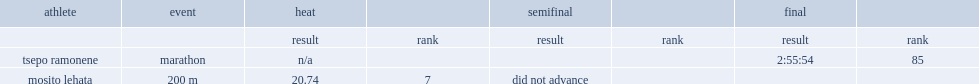I'm looking to parse the entire table for insights. Could you assist me with that? {'header': ['athlete', 'event', 'heat', '', 'semifinal', '', 'final', ''], 'rows': [['', '', 'result', 'rank', 'result', 'rank', 'result', 'rank'], ['tsepo ramonene', 'marathon', 'n/a', '', '', '', '2:55:54', '85'], ['mosito lehata', '200 m', '20.74', '7', 'did not advance', '', '', '']]} Lehata competed in the 200 metres, finishing seventh of all competitors, how many seconds with a time of? 20.74. 